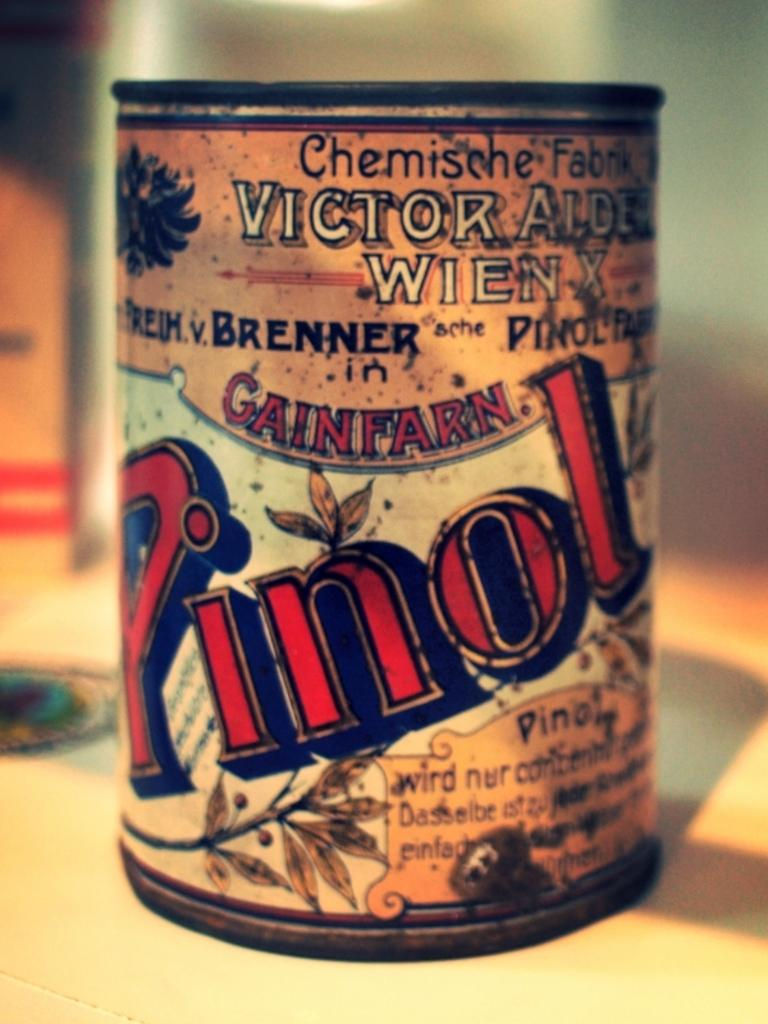<image>
Summarize the visual content of the image. An old, rusty and mottled can of Pinol. 